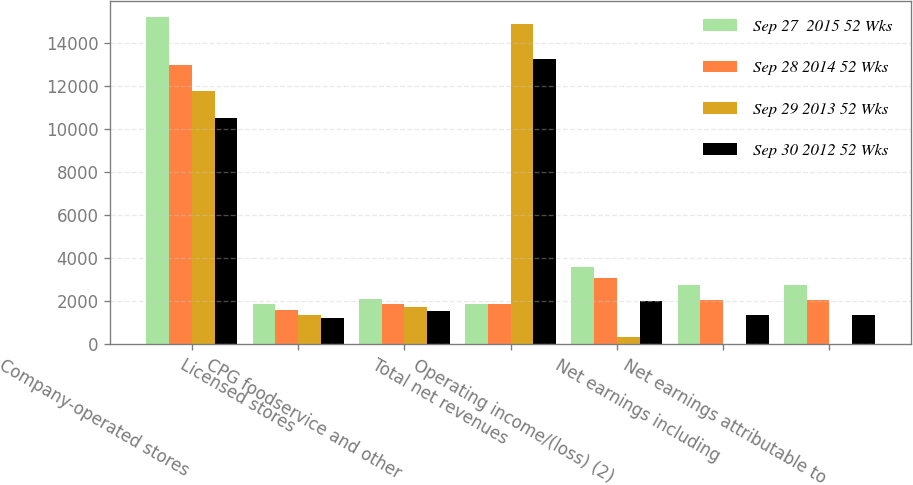Convert chart to OTSL. <chart><loc_0><loc_0><loc_500><loc_500><stacked_bar_chart><ecel><fcel>Company-operated stores<fcel>Licensed stores<fcel>CPG foodservice and other<fcel>Total net revenues<fcel>Operating income/(loss) (2)<fcel>Net earnings including<fcel>Net earnings attributable to<nl><fcel>Sep 27  2015 52 Wks<fcel>15197.3<fcel>1861.9<fcel>2103.5<fcel>1871.6<fcel>3601<fcel>2759.3<fcel>2757.4<nl><fcel>Sep 28 2014 52 Wks<fcel>12977.9<fcel>1588.6<fcel>1881.3<fcel>1871.6<fcel>3081.1<fcel>2067.7<fcel>2068.1<nl><fcel>Sep 29 2013 52 Wks<fcel>11793.2<fcel>1360.5<fcel>1713.1<fcel>14866.8<fcel>325.4<fcel>8.8<fcel>8.3<nl><fcel>Sep 30 2012 52 Wks<fcel>10534.5<fcel>1210.3<fcel>1532<fcel>13276.8<fcel>1997.4<fcel>1384.7<fcel>1383.8<nl></chart> 